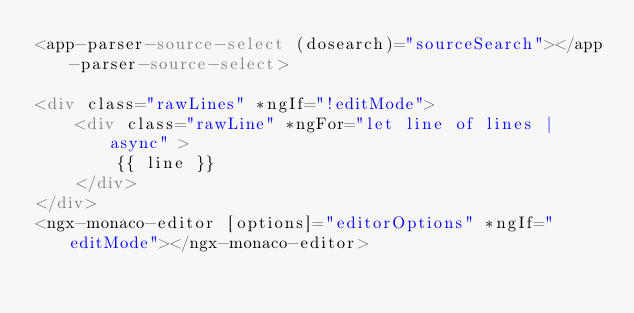<code> <loc_0><loc_0><loc_500><loc_500><_HTML_><app-parser-source-select (dosearch)="sourceSearch"></app-parser-source-select>

<div class="rawLines" *ngIf="!editMode">
    <div class="rawLine" *ngFor="let line of lines | async" >
        {{ line }}
    </div>
</div>
<ngx-monaco-editor [options]="editorOptions" *ngIf="editMode"></ngx-monaco-editor>
</code> 